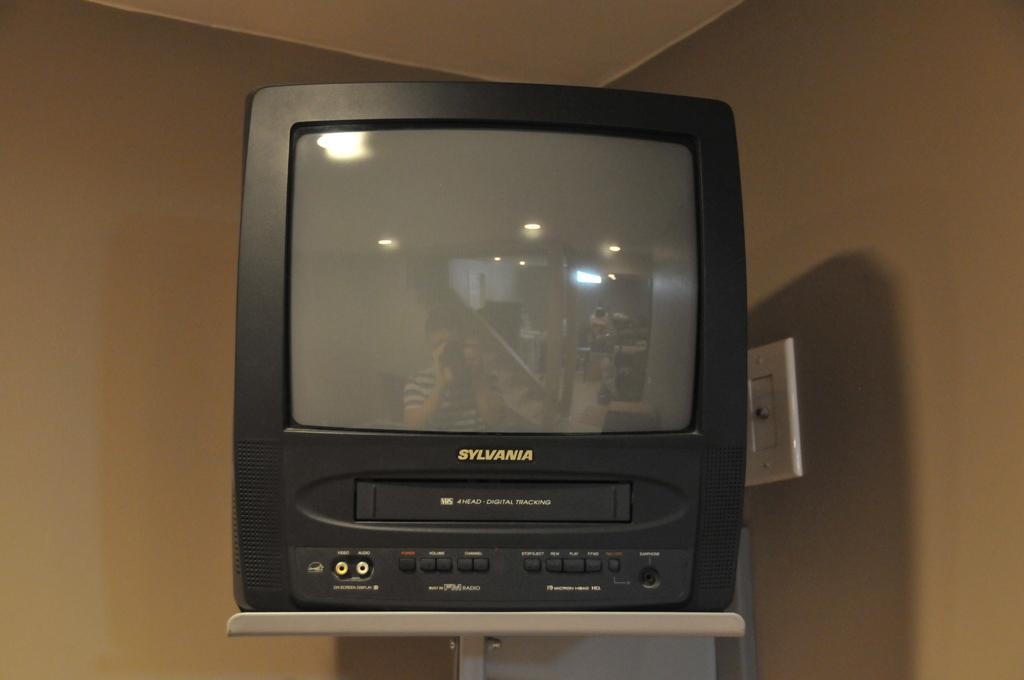<image>
Provide a brief description of the given image. An old Sylvania tv is on a stand attached to a wall. 